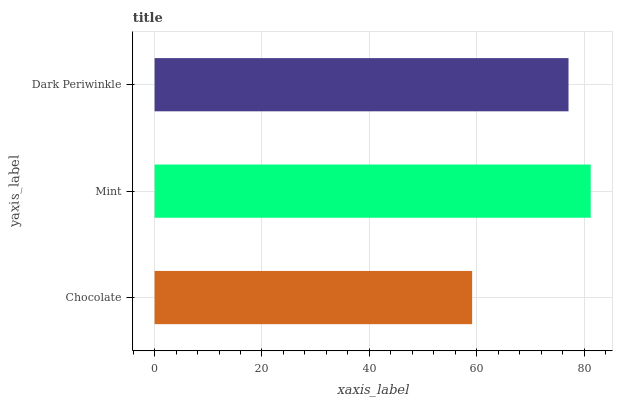Is Chocolate the minimum?
Answer yes or no. Yes. Is Mint the maximum?
Answer yes or no. Yes. Is Dark Periwinkle the minimum?
Answer yes or no. No. Is Dark Periwinkle the maximum?
Answer yes or no. No. Is Mint greater than Dark Periwinkle?
Answer yes or no. Yes. Is Dark Periwinkle less than Mint?
Answer yes or no. Yes. Is Dark Periwinkle greater than Mint?
Answer yes or no. No. Is Mint less than Dark Periwinkle?
Answer yes or no. No. Is Dark Periwinkle the high median?
Answer yes or no. Yes. Is Dark Periwinkle the low median?
Answer yes or no. Yes. Is Mint the high median?
Answer yes or no. No. Is Mint the low median?
Answer yes or no. No. 